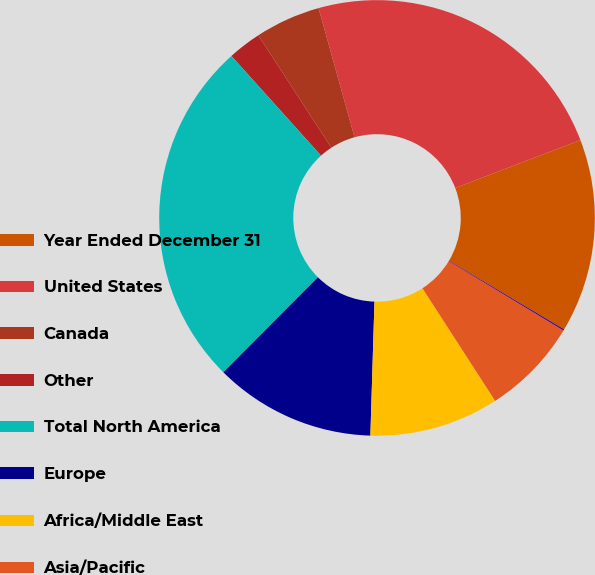Convert chart. <chart><loc_0><loc_0><loc_500><loc_500><pie_chart><fcel>Year Ended December 31<fcel>United States<fcel>Canada<fcel>Other<fcel>Total North America<fcel>Europe<fcel>Africa/Middle East<fcel>Asia/Pacific<fcel>South America<nl><fcel>14.36%<fcel>23.51%<fcel>4.85%<fcel>2.48%<fcel>25.88%<fcel>11.98%<fcel>9.61%<fcel>7.23%<fcel>0.1%<nl></chart> 